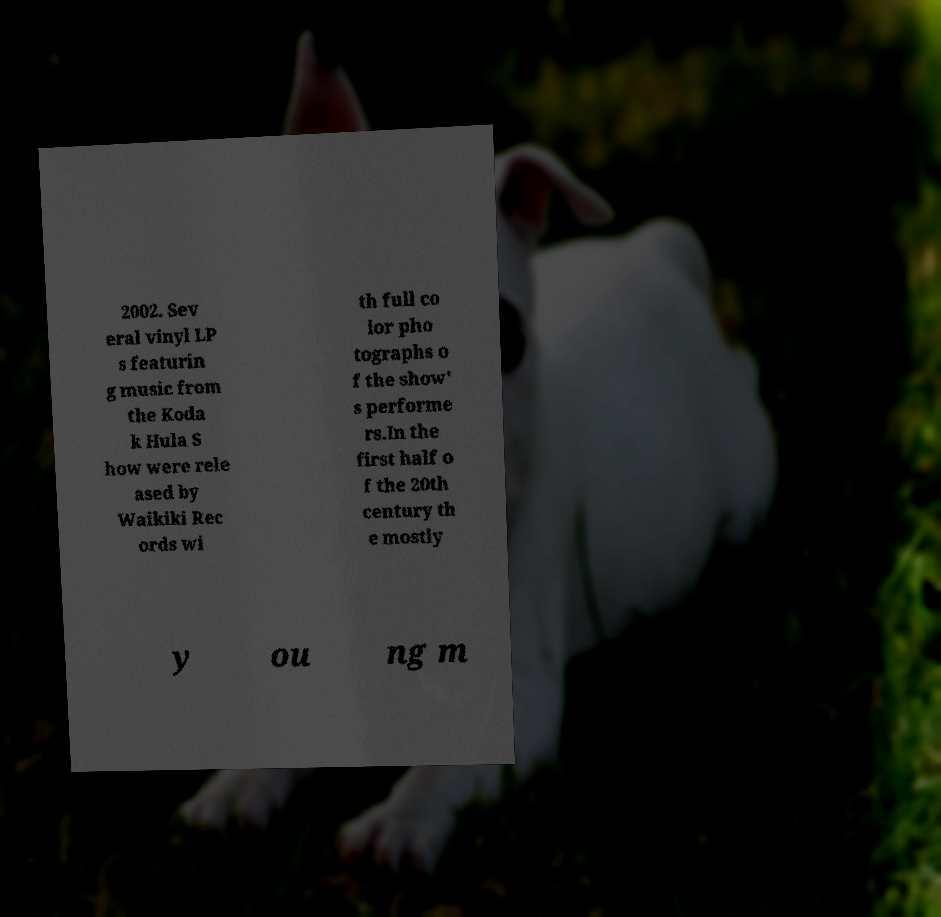What messages or text are displayed in this image? I need them in a readable, typed format. 2002. Sev eral vinyl LP s featurin g music from the Koda k Hula S how were rele ased by Waikiki Rec ords wi th full co lor pho tographs o f the show' s performe rs.In the first half o f the 20th century th e mostly y ou ng m 